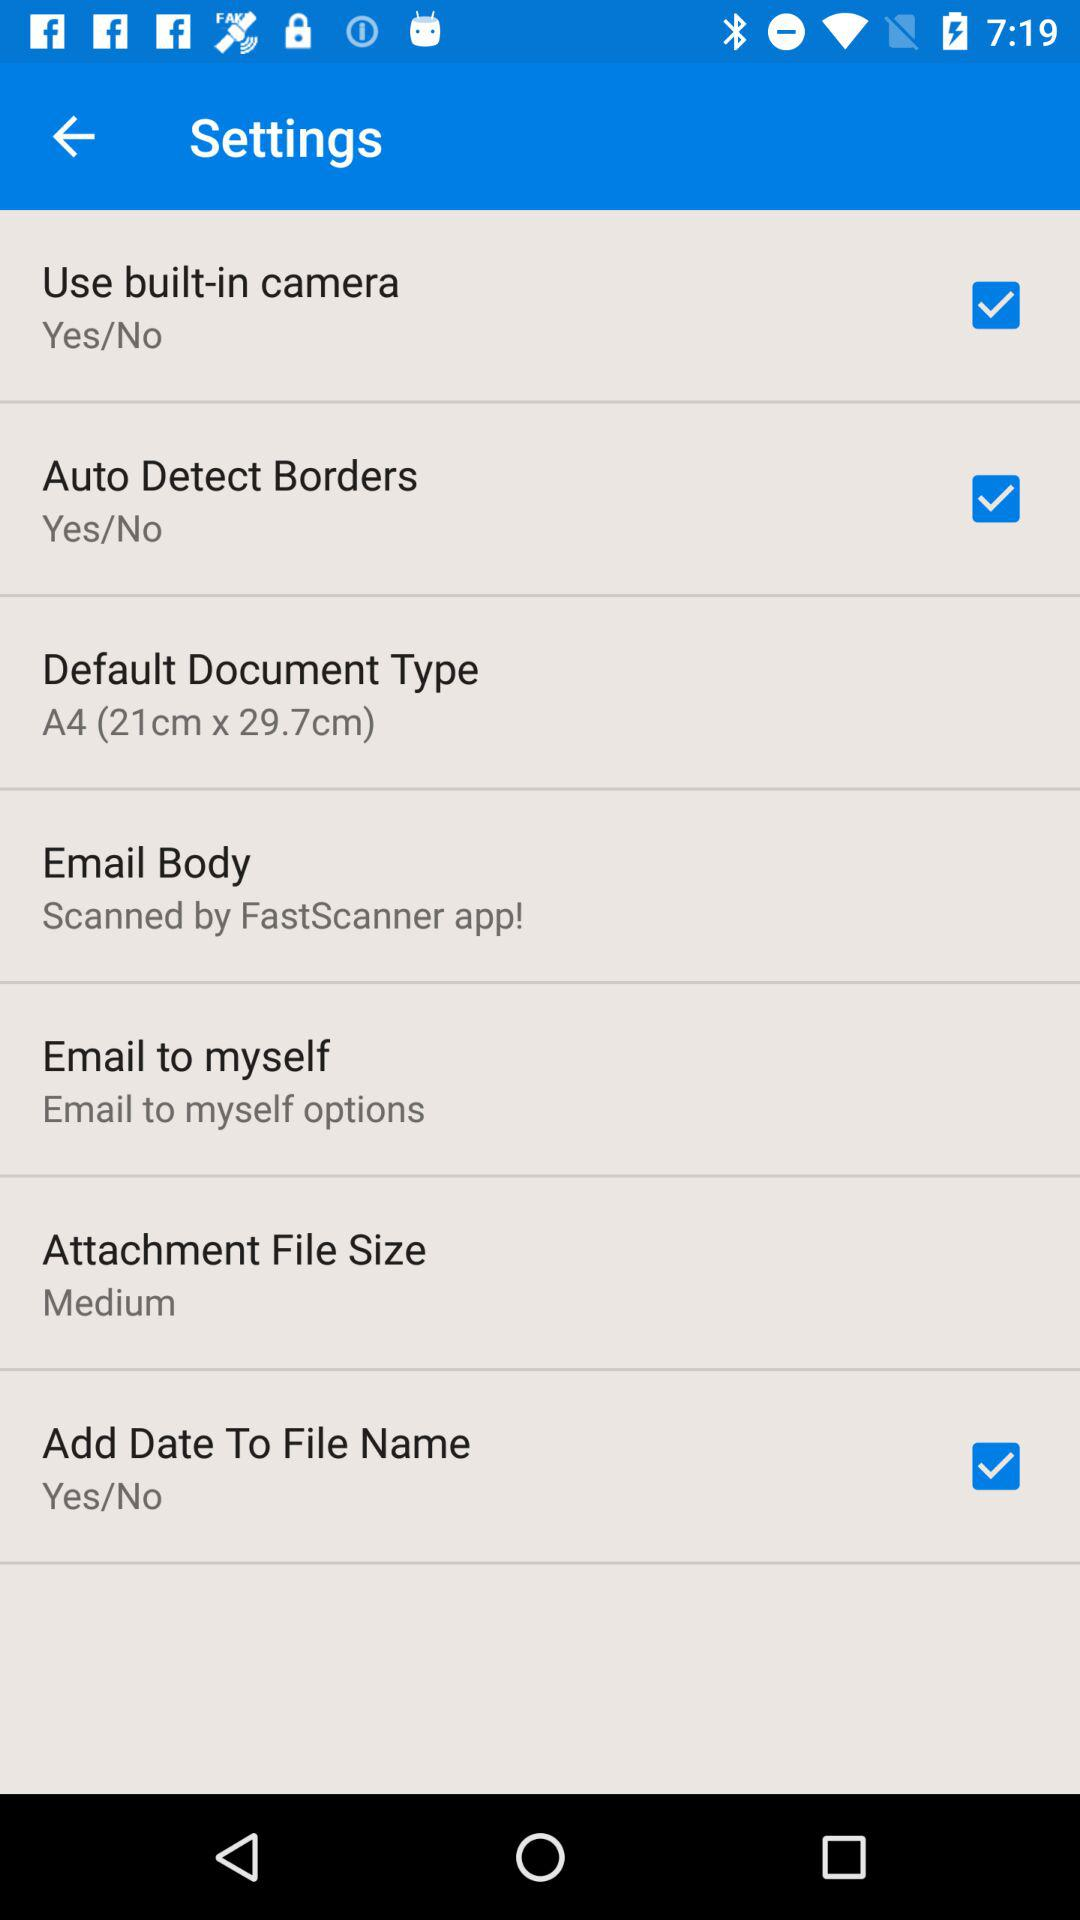What is the attachment file size? The attachment file size is "Medium". 